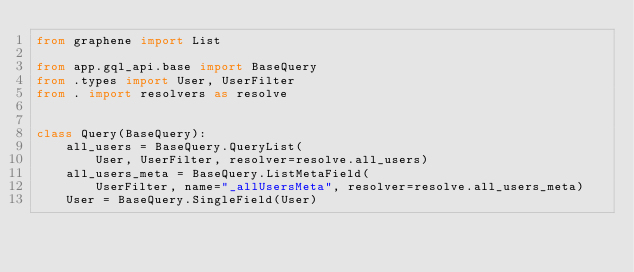Convert code to text. <code><loc_0><loc_0><loc_500><loc_500><_Python_>from graphene import List

from app.gql_api.base import BaseQuery
from .types import User, UserFilter
from . import resolvers as resolve


class Query(BaseQuery):
    all_users = BaseQuery.QueryList(
        User, UserFilter, resolver=resolve.all_users)
    all_users_meta = BaseQuery.ListMetaField(
        UserFilter, name="_allUsersMeta", resolver=resolve.all_users_meta)
    User = BaseQuery.SingleField(User)
</code> 